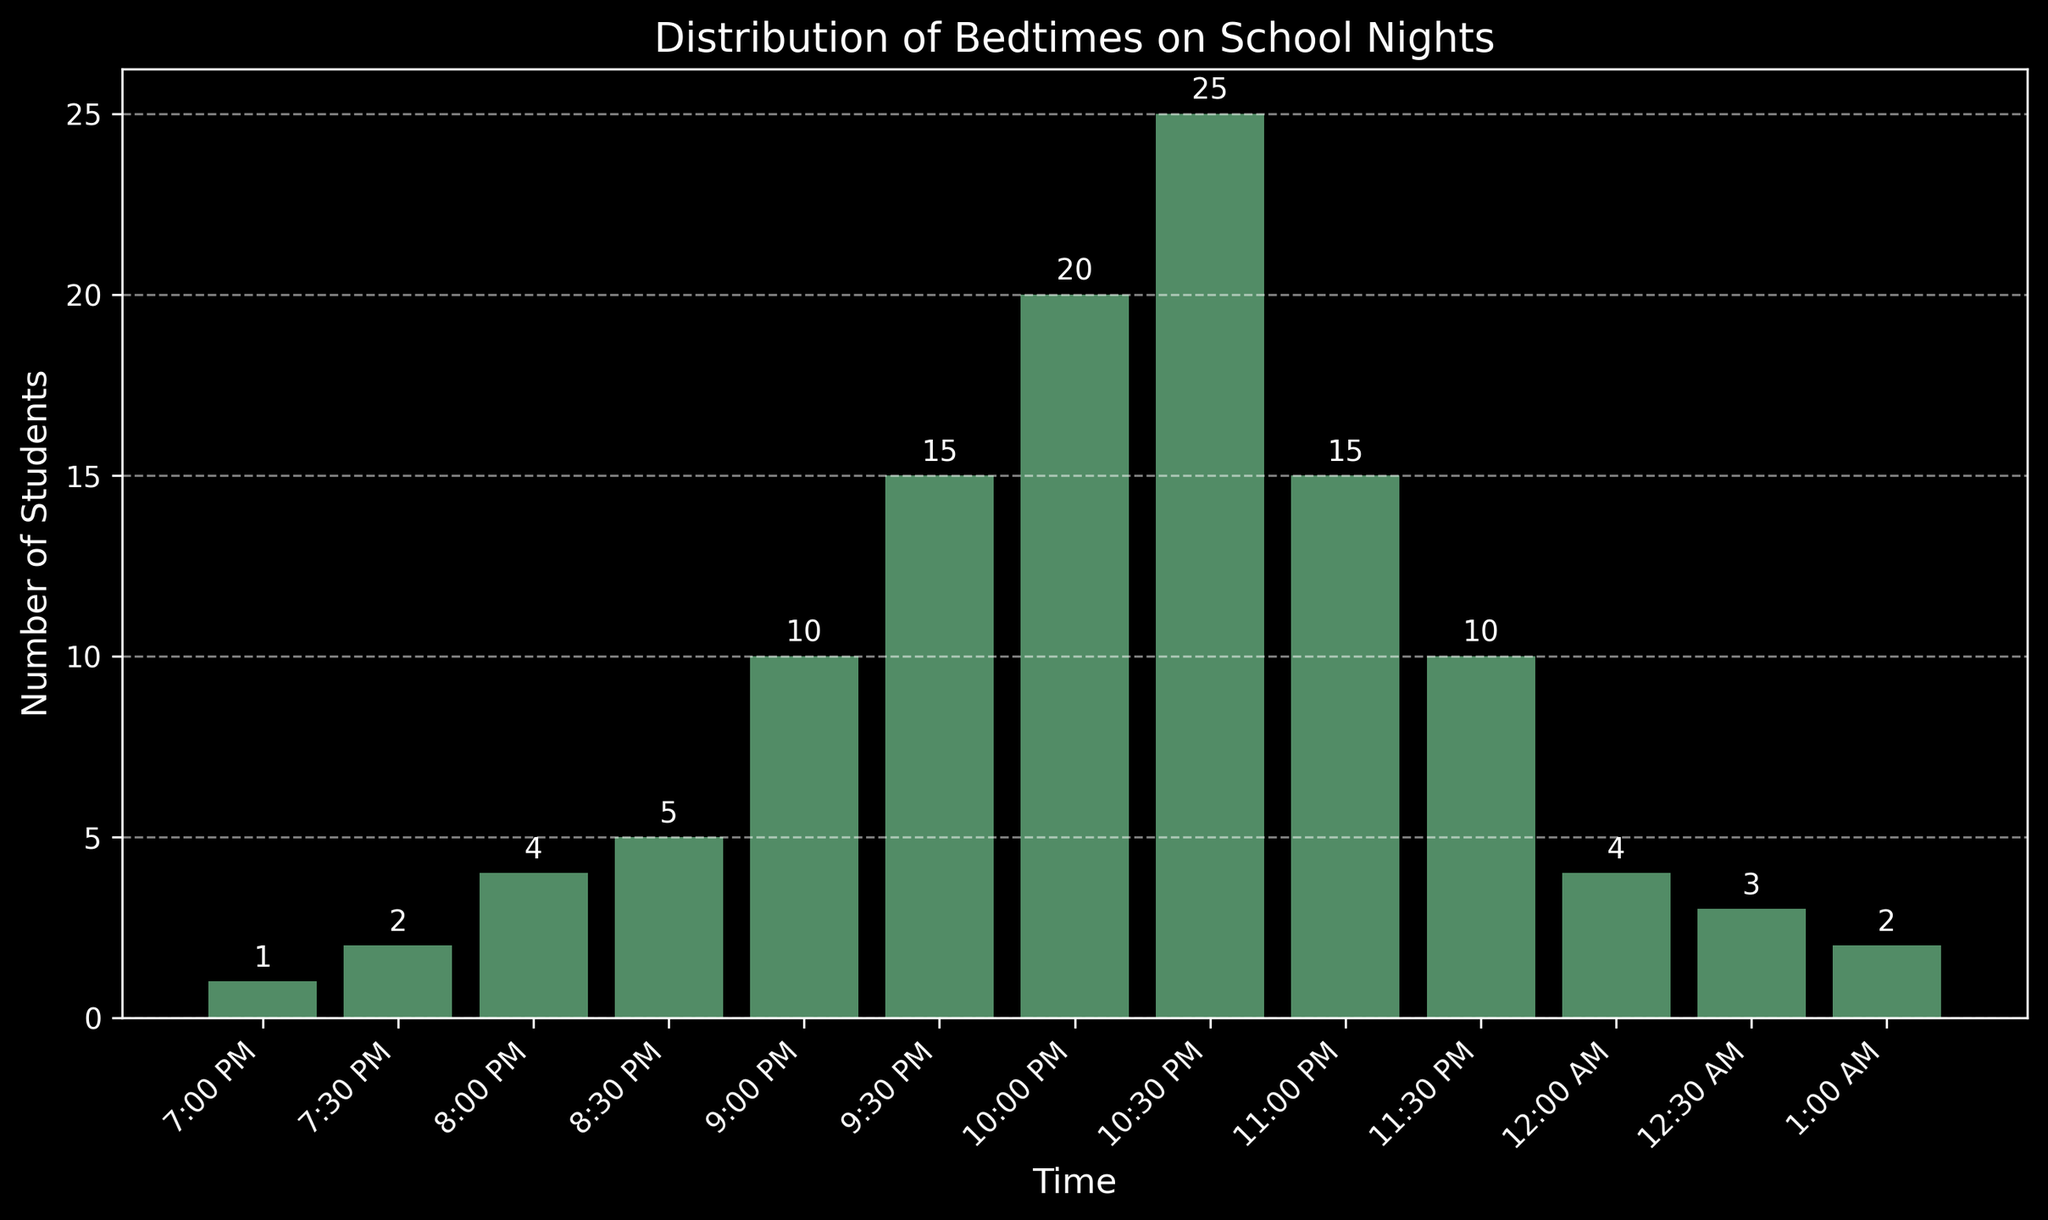What time do the most students go to bed? The tallest bar in the histogram represents the time with the highest count of students. The bar at 10:30 PM is the tallest.
Answer: 10:30 PM Which bedtime has a higher count, 9:00 PM or 11:00 PM? By comparing the heights of the bars at 9:00 PM and 11:00 PM, we see that the bar at 10:00 PM is higher.
Answer: 10:00 PM How many students go to bed between 9:00 PM and 10:30 PM, inclusive? Sum the counts of students from 9:00 PM, 9:30 PM, 10:00 PM, and 10:30 PM: 10 + 15 + 20 + 25.
Answer: 70 At what time do fewer students go to bed, 7:30 PM or 12:00 AM? Compare the heights of the bars at 7:30 PM and 12:00 AM. The bar at 7:30 PM is taller than the bar at 12:00 AM.
Answer: 12:00 AM What is the total number of students who go to bed after 11:00 PM? Sum the counts for 11:30 PM, 12:00 AM, 12:30 AM, and 1:00 AM: 10 + 4 + 3 + 2.
Answer: 19 Which bedtime has an equal count to the students who go to bed at 7:00 PM and 7:30 PM combined? Sum the counts for 7:00 PM and 7:30 PM, which gives 1 + 2 = 3, equal to the count for 12:30 AM.
Answer: 12:30 AM What percentage of students go to bed at 10:00 PM? The count at 10:00 PM is 20. The total number of students is 111. The percentage is (20 / 111) * 100.
Answer: 18% Is the number of students going to bed at 11:30 PM greater than the total of those going to bed at 12:00 AM to 1:00 AM? Compare the count at 11:30 PM (which is 10) with the sum from 12:00 AM to 1:00 AM (4 + 3 + 2 = 9).
Answer: Yes How many more students go to bed at 10:30 PM compared to 8:30 PM? Subtract the count at 8:30 PM (5) from the count at 10:30 PM (25).
Answer: 20 